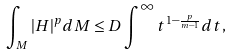Convert formula to latex. <formula><loc_0><loc_0><loc_500><loc_500>\int _ { M } | H | ^ { p } d M \leq D \int ^ { \infty } t ^ { 1 - \frac { p } { m - 1 } } d t ,</formula> 